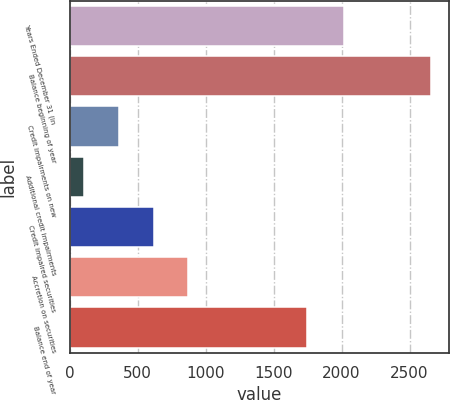Convert chart. <chart><loc_0><loc_0><loc_500><loc_500><bar_chart><fcel>Years Ended December 31 (in<fcel>Balance beginning of year<fcel>Credit impairments on new<fcel>Additional credit impairments<fcel>Credit impaired securities<fcel>Accretion on securities<fcel>Balance end of year<nl><fcel>2015<fcel>2659<fcel>364<fcel>109<fcel>619<fcel>874<fcel>1747<nl></chart> 